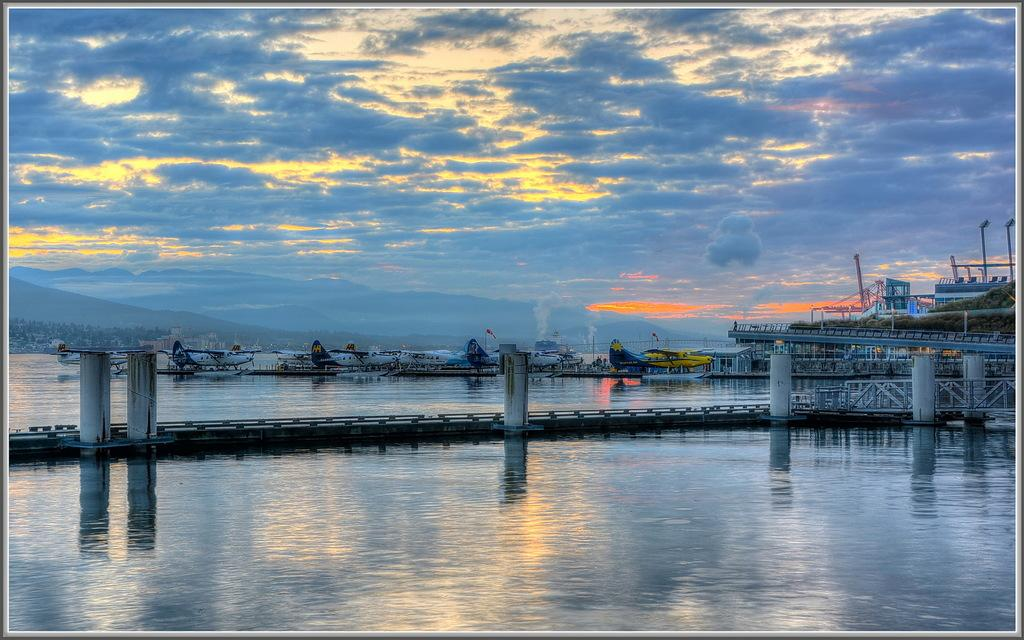What is located in the middle of the picture? There is a river and airplanes in the middle of the picture. Can you describe the sky in the background of the image? There are clouds in the sky in the background of the image. What type of street can be seen in the image? There is no street present in the image; it features a river and airplanes. What is the interest rate for the operation depicted in the image? There is no operation or financial transaction depicted in the image, so it is not possible to determine an interest rate. 